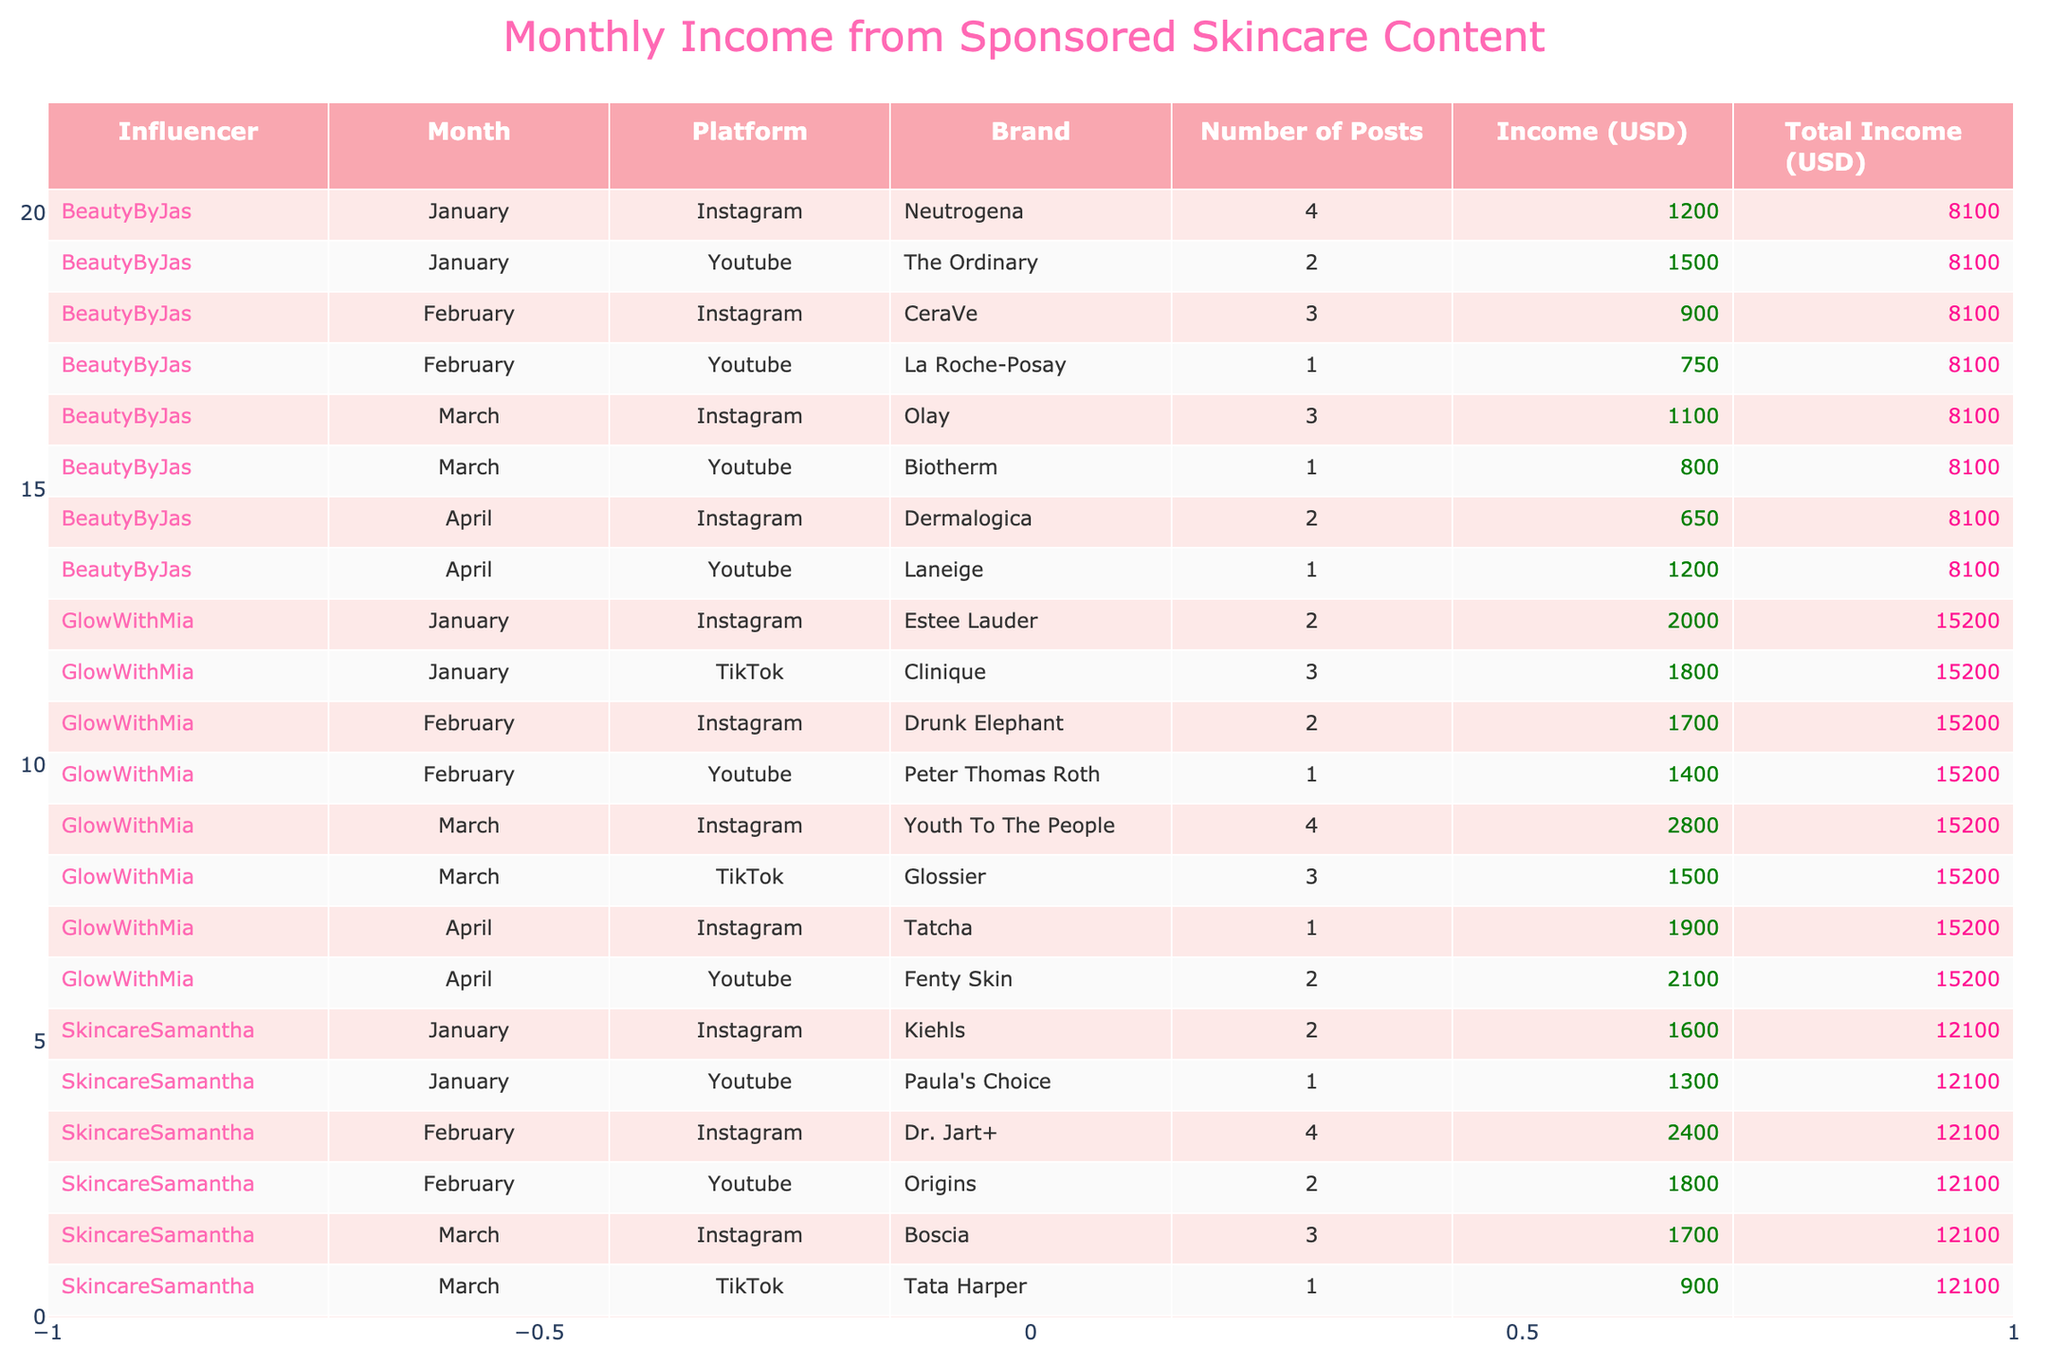What is the total income generated by GlowWithMia in March? In March, GlowWithMia has two entries: one on Instagram for 2800 USD and one on TikTok for 1500 USD. By adding these two amounts together (2800 + 1500), we find that the total income is 4300 USD.
Answer: 4300 Which platform did SkincareSamantha earn more income from in January? In January, SkincareSamantha earned 1600 USD from Instagram and 1300 USD from YouTube. Since 1600 is greater than 1300, SkincareSamantha earned more on Instagram.
Answer: Instagram What is the average income per post for BeautyByJas in February? BeautyByJas had a total income of 900 USD from 3 Instagram posts and 750 USD from 1 YouTube post, giving a total income of 1650 USD for February. The total number of posts is 4. To find the average, we calculate 1650 / 4 = 412.5 USD per post.
Answer: 412.5 Did any influencer earn more than 2500 USD in a single month? Reviewing the table, in March, GlowWithMia earned 2800 USD, which is more than 2500 USD. Therefore, the statement is true.
Answer: Yes What is the total income for SkincareSamantha from all months combined? To find the total income, we sum the amounts for each month: January (1600 + 1300), February (2400 + 1800), March (1700 + 900), and April (1300 + 1100), resulting in 1600 + 1300 + 2400 + 1800 + 1700 + 900 + 1300 + 1100 = 11000 USD.
Answer: 11000 What is the income difference between the highest and lowest earner in January? From the table, the highest income in January is 2000 USD (GlowWithMia from Instagram), and the lowest is 1200 USD (BeautyByJas from Instagram). The difference is 2000 - 1200 = 800 USD.
Answer: 800 How much income did the brand Neutrogena generate for BeautyByJas in January? In January, BeautyByJas earned 1200 USD from Neutrogena for 4 posts on Instagram. Hence, the income generated by Neutrogena for that month is 1200 USD.
Answer: 1200 Which influencer made the most money in February? In February, GlowWithMia earned 1700 USD from Instagram and 1400 USD from YouTube, totaling 3100 USD. In contrast, SkincareSamantha earned 2400 USD from Instagram and 1800 USD from YouTube, totaling 4200 USD. Therefore, SkincareSamantha made the most money in February.
Answer: SkincareSamantha 